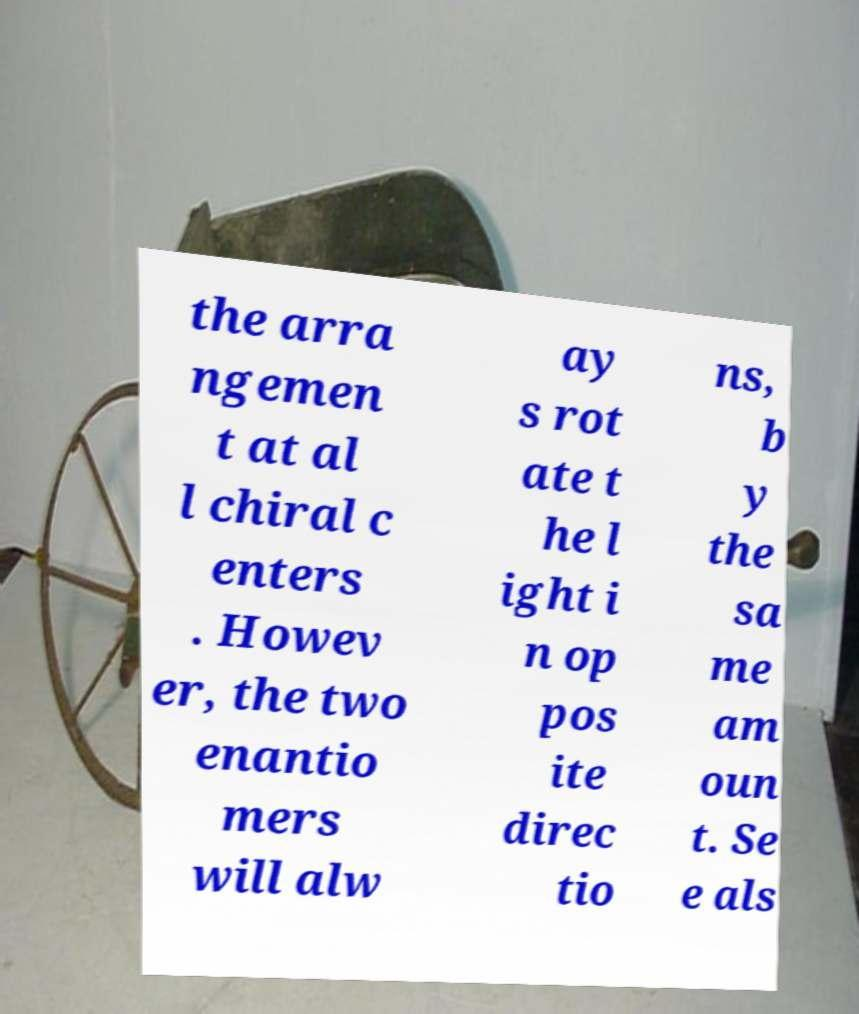I need the written content from this picture converted into text. Can you do that? the arra ngemen t at al l chiral c enters . Howev er, the two enantio mers will alw ay s rot ate t he l ight i n op pos ite direc tio ns, b y the sa me am oun t. Se e als 